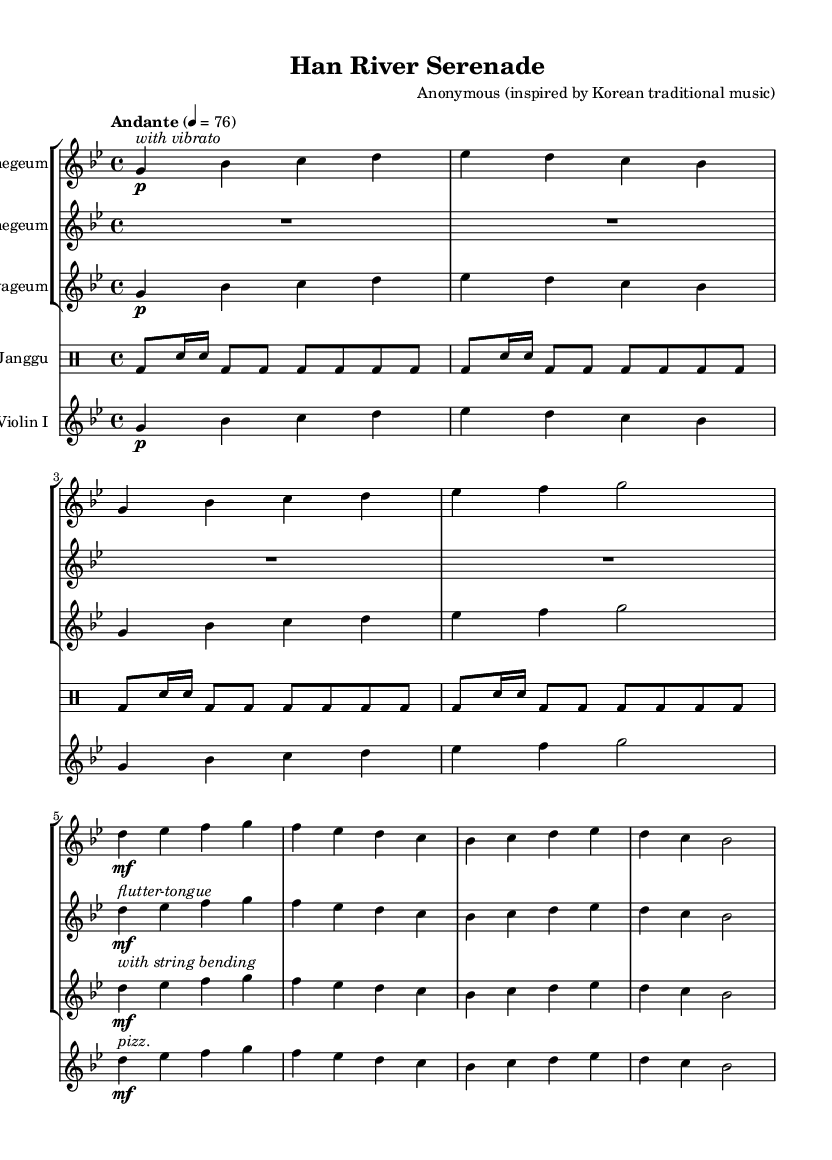What is the key signature of this music? The key signature is indicated at the beginning of the staff. It shows one flat (B flat), which signifies G minor.
Answer: G minor What is the time signature of this music? The time signature is found at the beginning, indicating the number of beats in each measure. It is shown as 4 over 4, meaning there are four beats per measure.
Answer: 4/4 What is the tempo marking for this piece? Tempo markings are typically written near the beginning of the score. Here it states "Andante" with a metronome marking of 76, suggesting a moderate walking pace.
Answer: Andante, 76 How many instruments are used in this symphony? By counting the distinct staves in the score, we see there are five sections, indicating five different instruments featured in this symphony.
Answer: Five Which instrument has a flutter-tongue marking? The markings for special techniques are shown directly under or above the corresponding notes. The Daegeum has the flutter-tongue notation marked in the first measure of its staff.
Answer: Daegeum What special technique is indicated for the Gayageum? The Gayageum's staff shows a note with the instruction "with string bending" clearly marked in the scoring, indicating a specific playing technique unique to its performance.
Answer: With string bending What is the rhythm pattern of the Janggu in the first four measures? To determine the rhythm pattern, we look at the drum notation provided. The first four measures consist of a combination of bass drum and snare hits following a repeated motif, where the bass drum (bd) sounds on the beats, and the snare (sn) adds syncopation.
Answer: Bass drum and snare pattern 